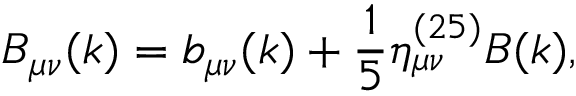Convert formula to latex. <formula><loc_0><loc_0><loc_500><loc_500>B _ { \mu \nu } ( k ) = b _ { \mu \nu } ( k ) + \frac { 1 } { 5 } \eta _ { \mu \nu } ^ { ( 2 5 ) } B ( k ) ,</formula> 